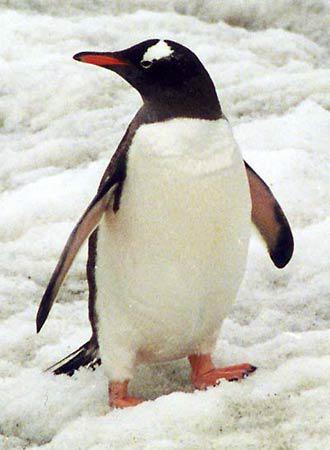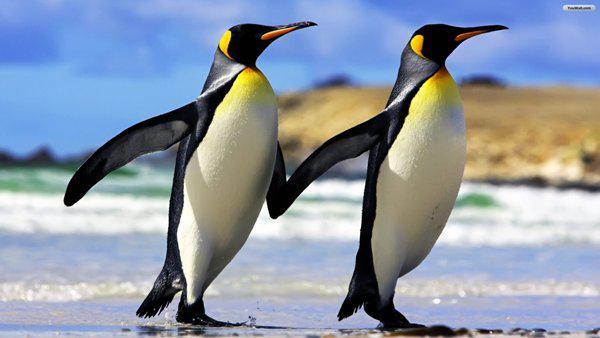The first image is the image on the left, the second image is the image on the right. Given the left and right images, does the statement "there is only one penguin on the right image" hold true? Answer yes or no. No. 